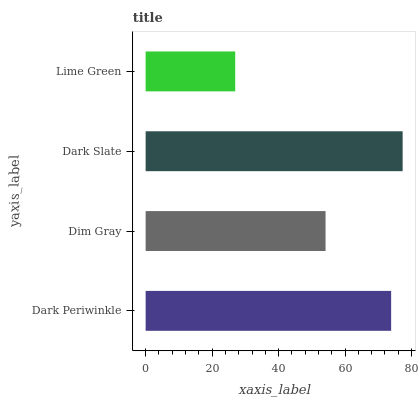Is Lime Green the minimum?
Answer yes or no. Yes. Is Dark Slate the maximum?
Answer yes or no. Yes. Is Dim Gray the minimum?
Answer yes or no. No. Is Dim Gray the maximum?
Answer yes or no. No. Is Dark Periwinkle greater than Dim Gray?
Answer yes or no. Yes. Is Dim Gray less than Dark Periwinkle?
Answer yes or no. Yes. Is Dim Gray greater than Dark Periwinkle?
Answer yes or no. No. Is Dark Periwinkle less than Dim Gray?
Answer yes or no. No. Is Dark Periwinkle the high median?
Answer yes or no. Yes. Is Dim Gray the low median?
Answer yes or no. Yes. Is Dim Gray the high median?
Answer yes or no. No. Is Dark Periwinkle the low median?
Answer yes or no. No. 